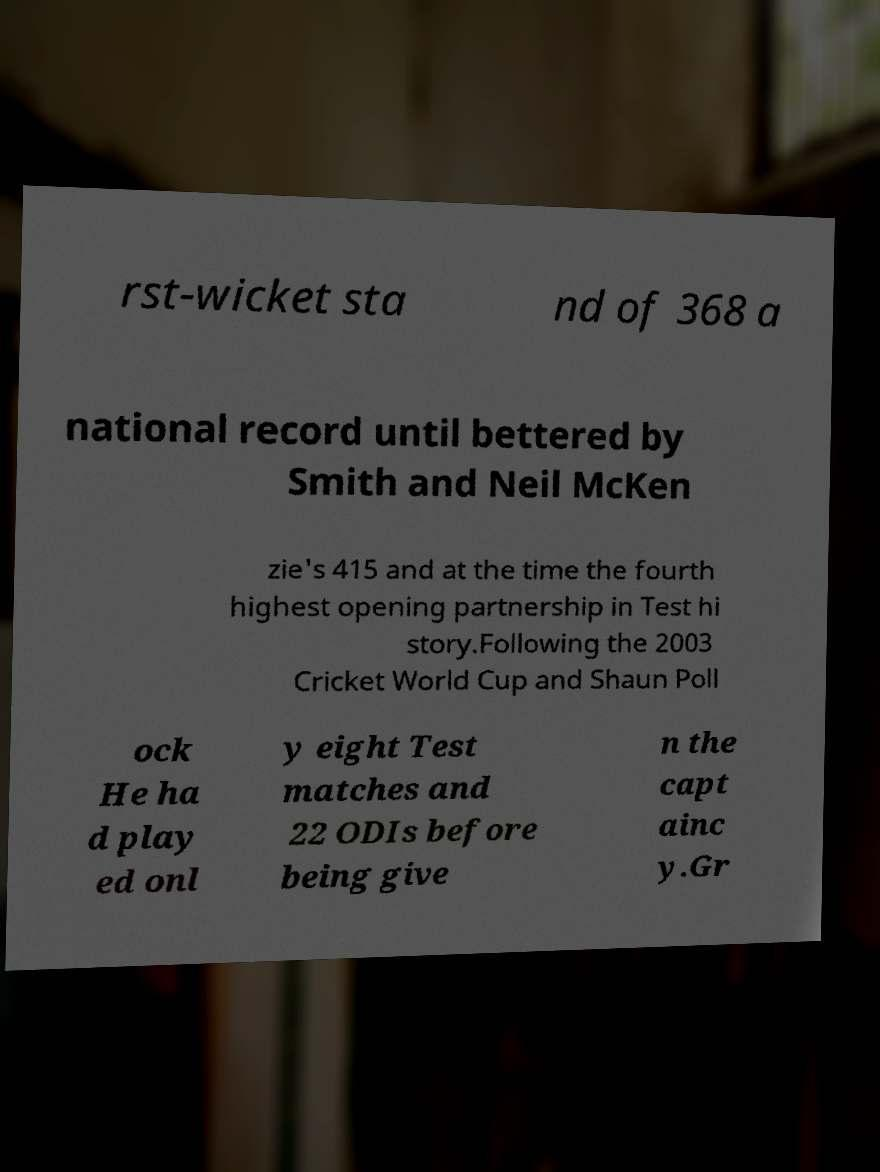Could you assist in decoding the text presented in this image and type it out clearly? rst-wicket sta nd of 368 a national record until bettered by Smith and Neil McKen zie's 415 and at the time the fourth highest opening partnership in Test hi story.Following the 2003 Cricket World Cup and Shaun Poll ock He ha d play ed onl y eight Test matches and 22 ODIs before being give n the capt ainc y.Gr 